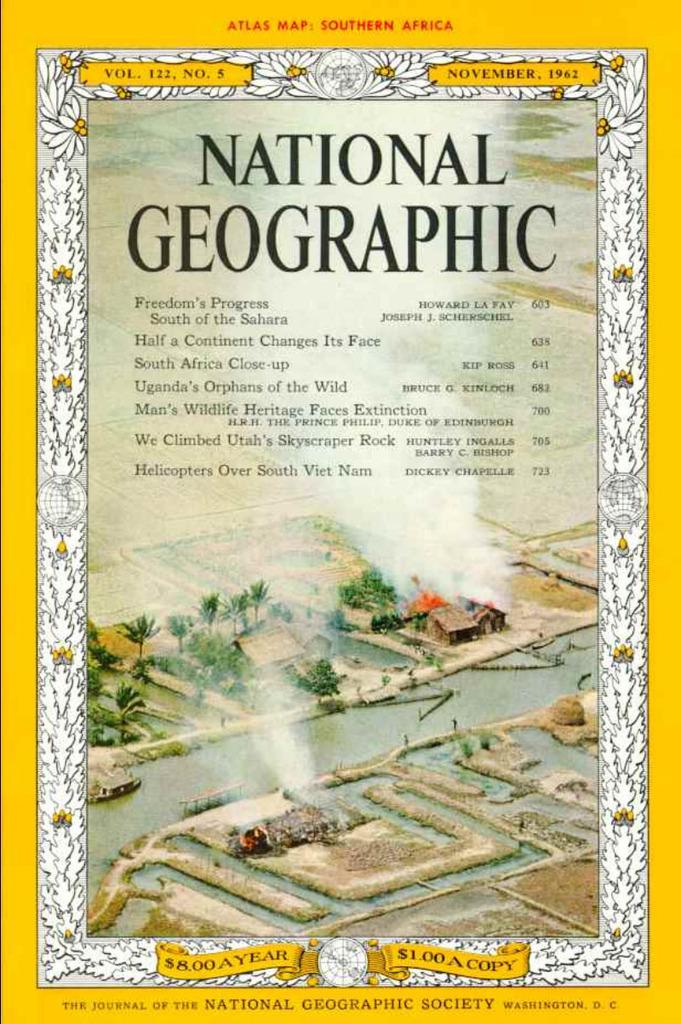How much is a copy of this national geographic?
Give a very brief answer. $1.00. What is the name of the book?
Offer a very short reply. National geographic. 